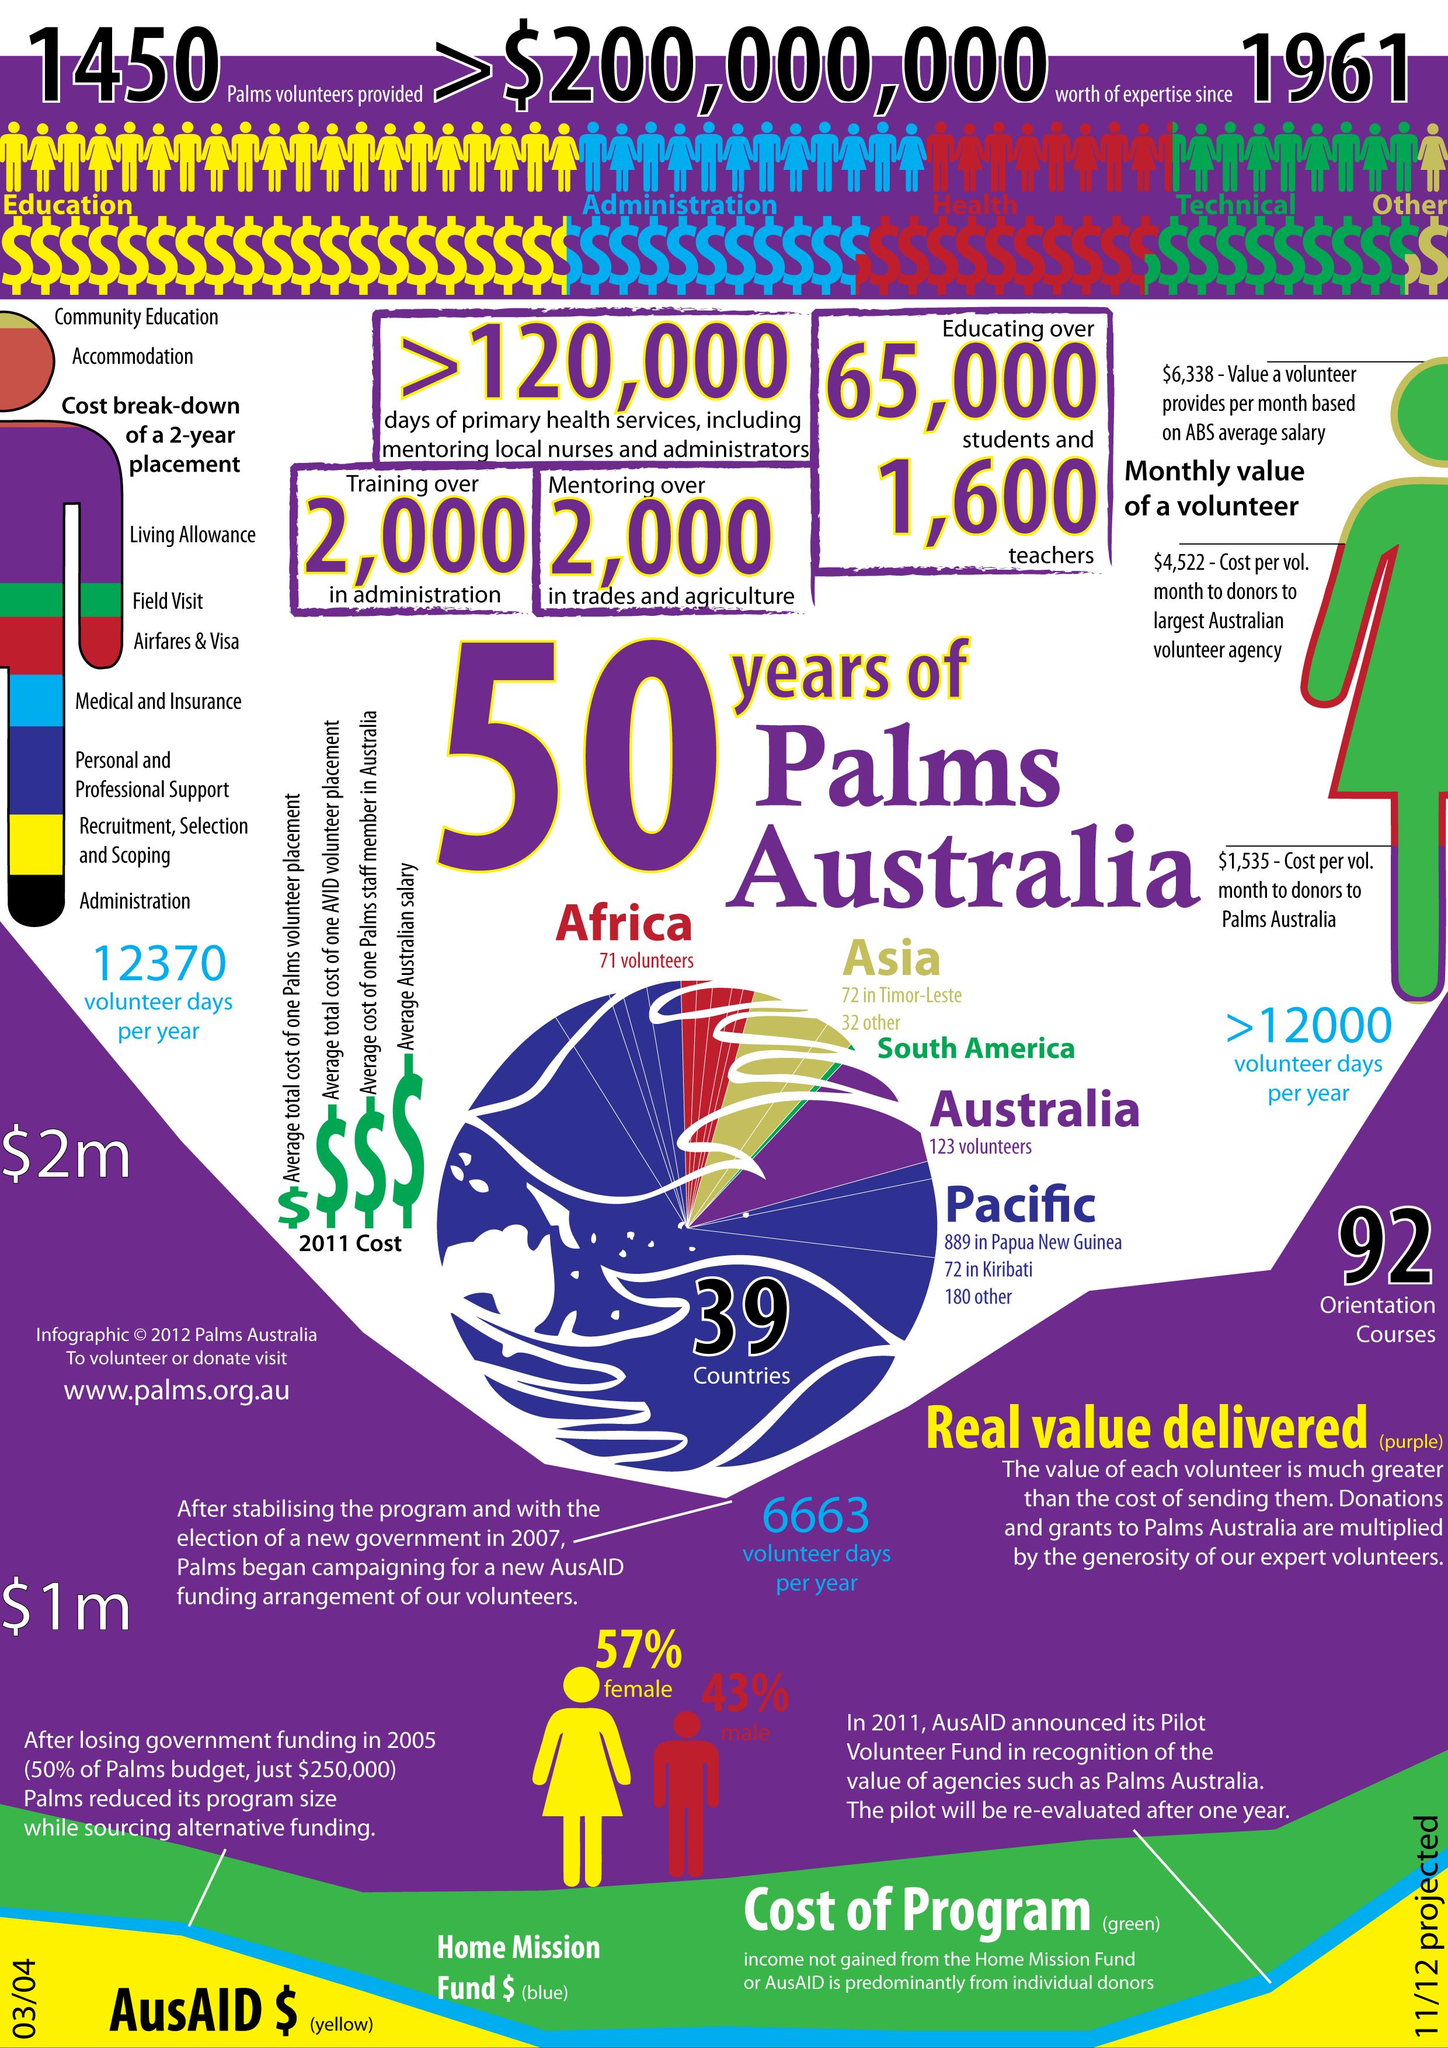Mention a couple of crucial points in this snapshot. It is estimated that approximately 2,000 individuals will be trained in the fields of trade and agriculture. There are 71 volunteers from Africa who have participated in the Palms Australia program. Palms Australia is educating approximately 65,000 students. Approximately 2,000 individuals are currently undergoing training in administration. Palms Australia employs approximately 1,600 teachers. 